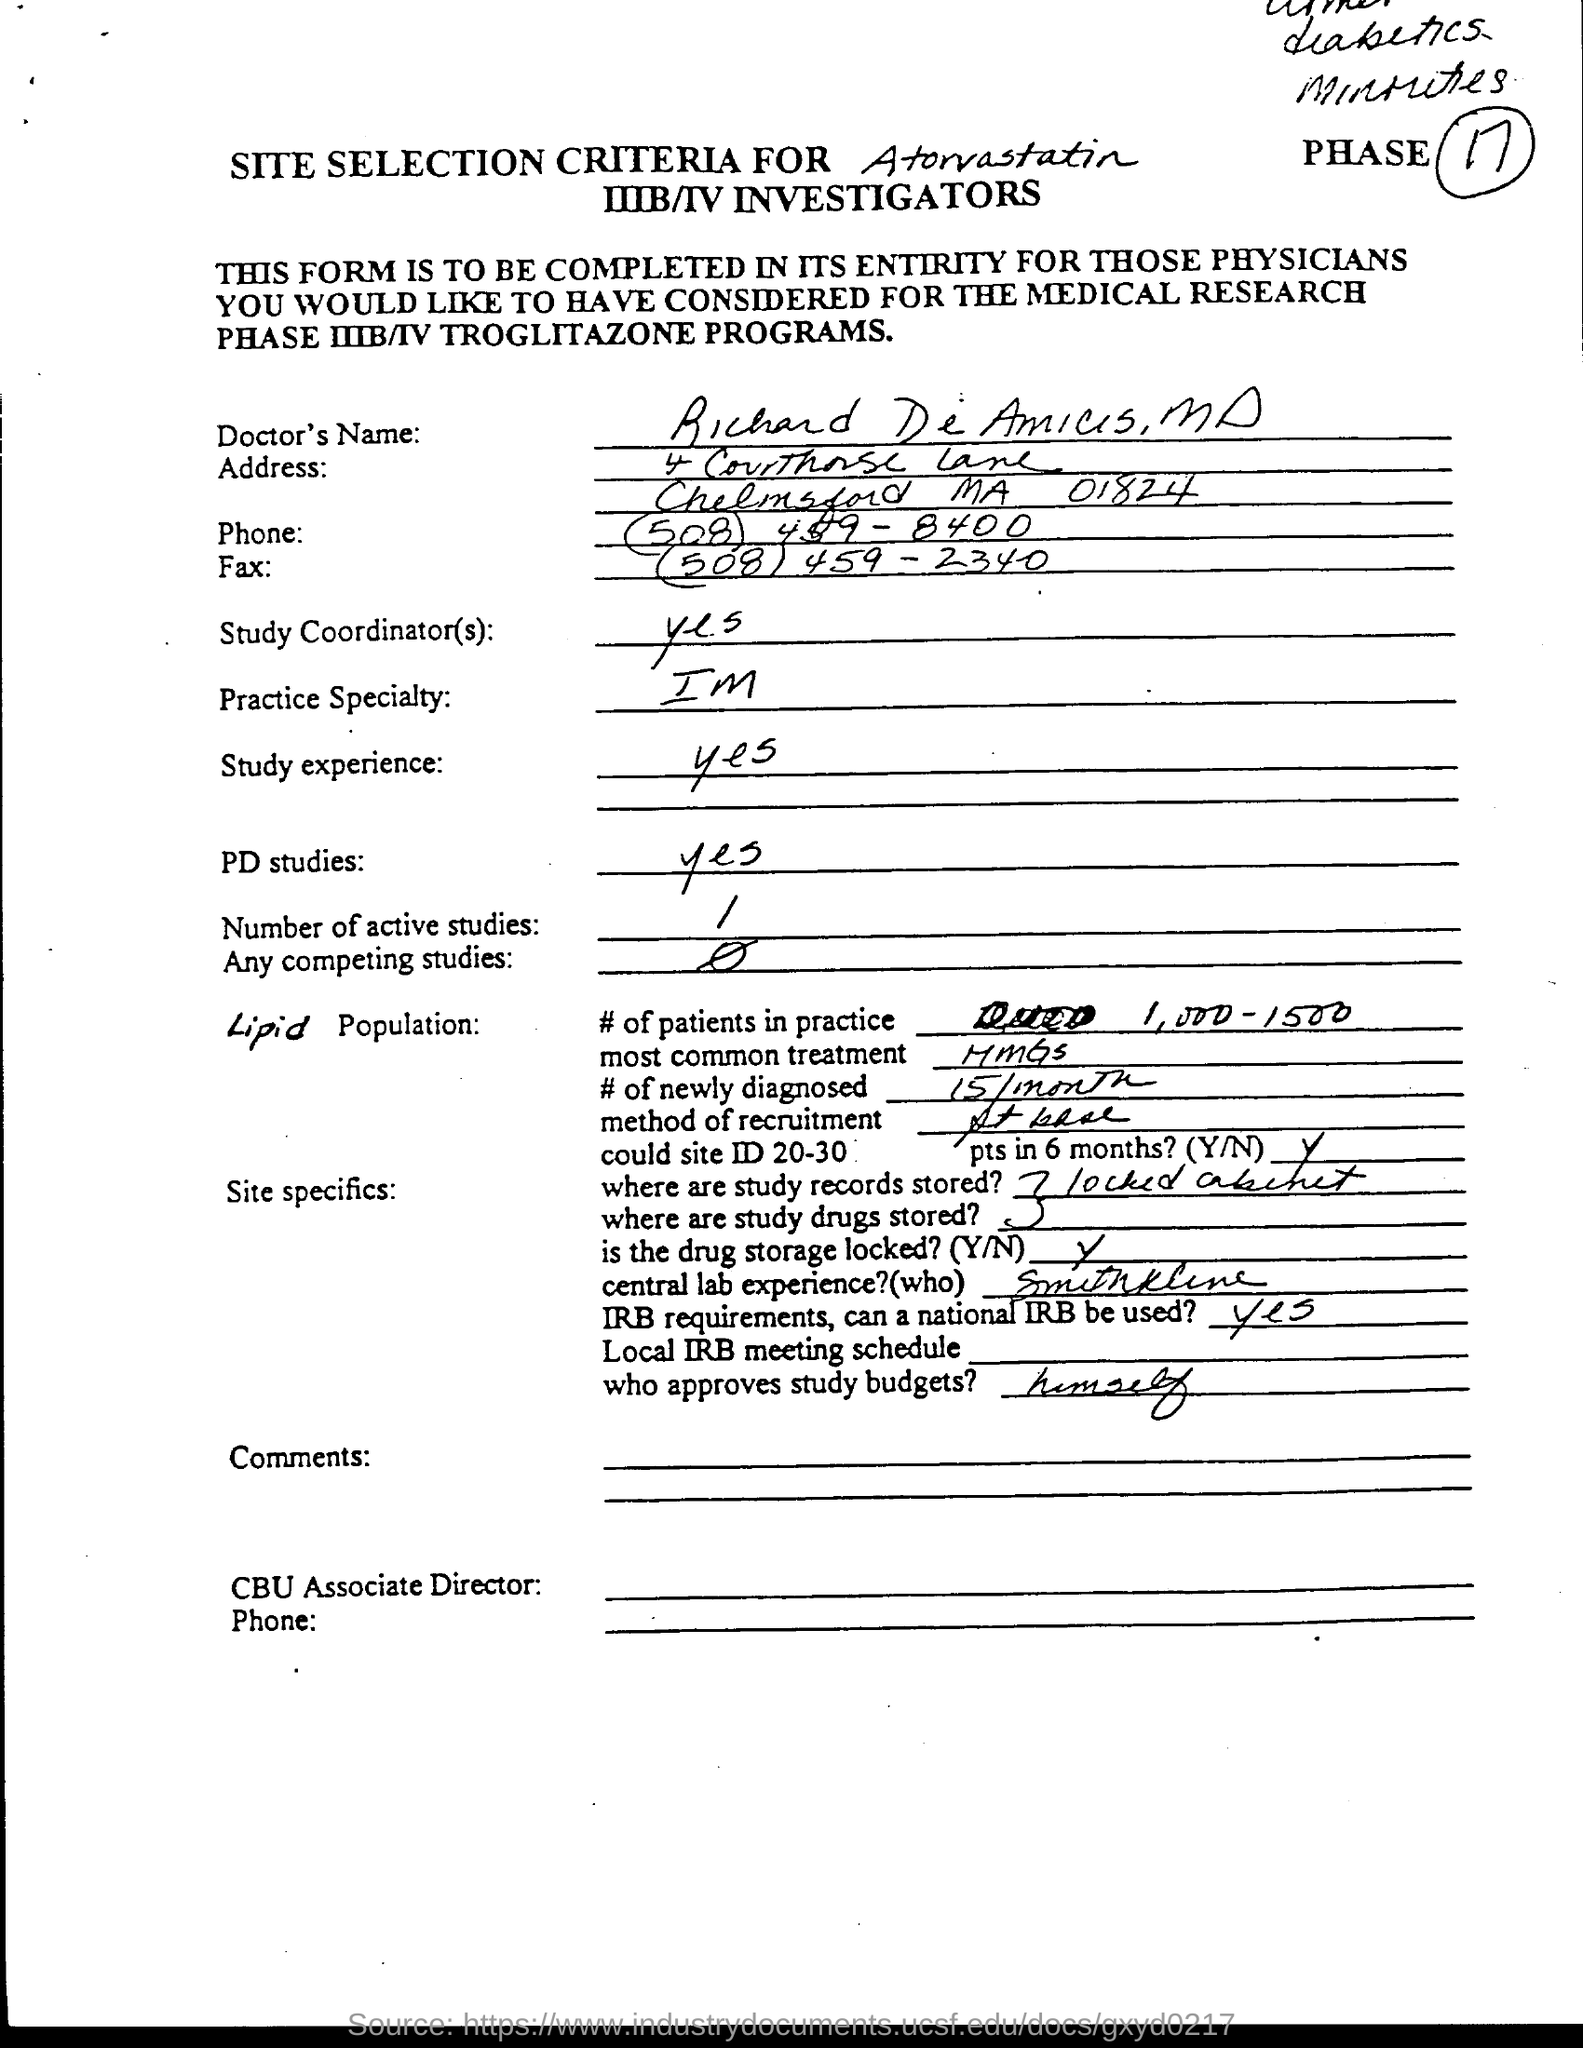Highlight a few significant elements in this photo. Study records and study drugs are stored in a locked cabinet. Approximately 15 patients are newly diagnosed with the condition each month. I am a specialist in the practice of IM. The phase number is 17... There is currently 1 active study. 